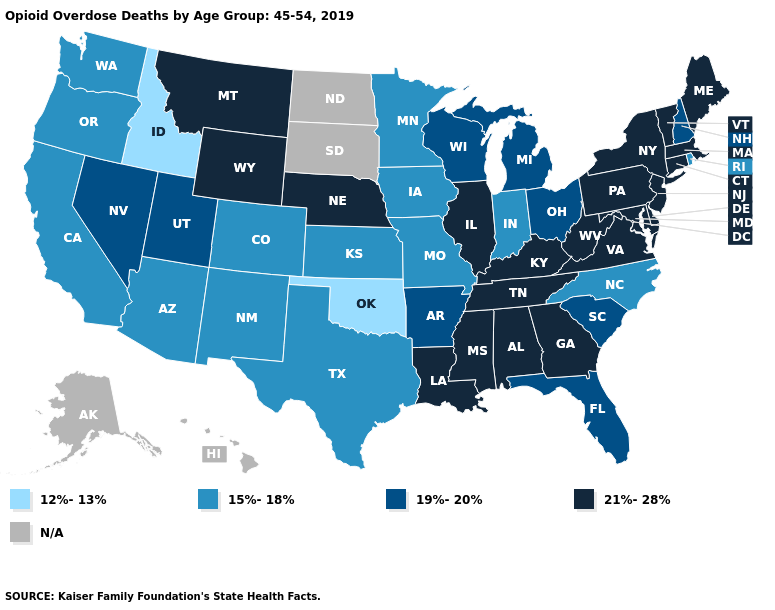What is the highest value in the South ?
Concise answer only. 21%-28%. Does Missouri have the highest value in the MidWest?
Concise answer only. No. What is the lowest value in the MidWest?
Write a very short answer. 15%-18%. Which states hav the highest value in the West?
Concise answer only. Montana, Wyoming. Name the states that have a value in the range 19%-20%?
Keep it brief. Arkansas, Florida, Michigan, Nevada, New Hampshire, Ohio, South Carolina, Utah, Wisconsin. What is the value of Arizona?
Concise answer only. 15%-18%. Does the map have missing data?
Give a very brief answer. Yes. Does Virginia have the highest value in the USA?
Answer briefly. Yes. What is the value of New Jersey?
Short answer required. 21%-28%. Name the states that have a value in the range N/A?
Give a very brief answer. Alaska, Hawaii, North Dakota, South Dakota. Name the states that have a value in the range 21%-28%?
Short answer required. Alabama, Connecticut, Delaware, Georgia, Illinois, Kentucky, Louisiana, Maine, Maryland, Massachusetts, Mississippi, Montana, Nebraska, New Jersey, New York, Pennsylvania, Tennessee, Vermont, Virginia, West Virginia, Wyoming. Name the states that have a value in the range 12%-13%?
Give a very brief answer. Idaho, Oklahoma. 